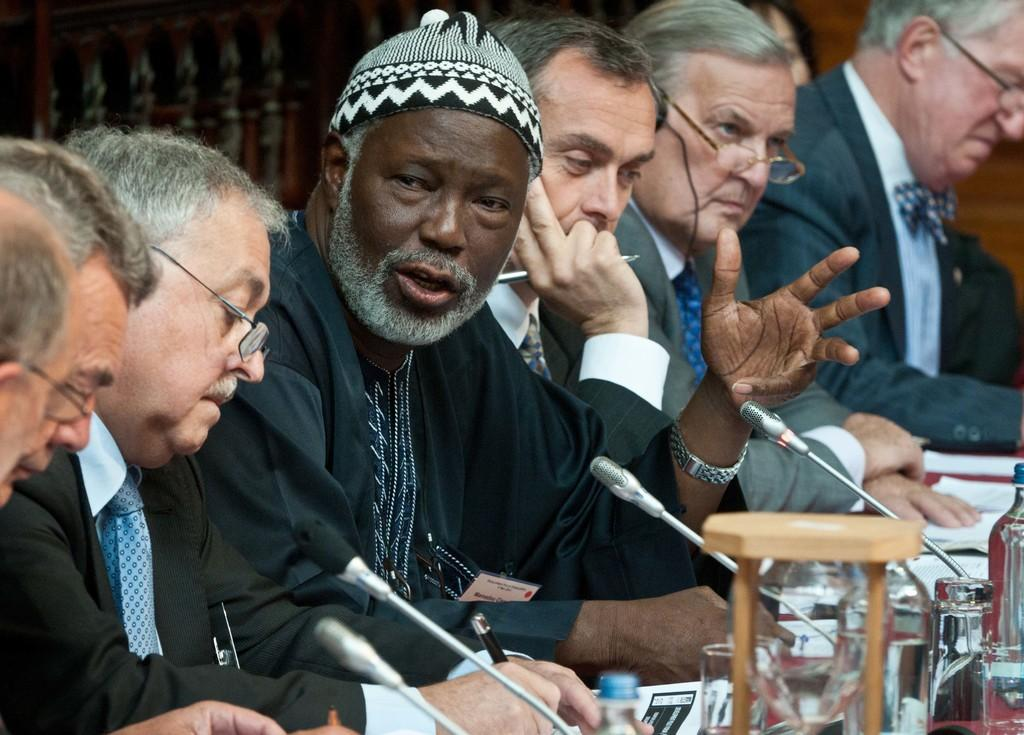What are the people in the image doing? There is a group of people sitting in the image, which suggests they might be engaged in a meeting or discussion. What items can be seen on the table in the image? There are papers, pens, glasses, bottles, and microphones on the table. What might the people be using the pens for? The pens on the table might be used for writing or taking notes during the meeting or discussion. What could the glasses and bottles be used for? The glasses and bottles on the table might be used for drinking water or other beverages during the meeting or discussion. How does the desk contribute to the reduction of pollution in the image? There is no desk present in the image, and therefore it cannot contribute to the reduction of pollution. 